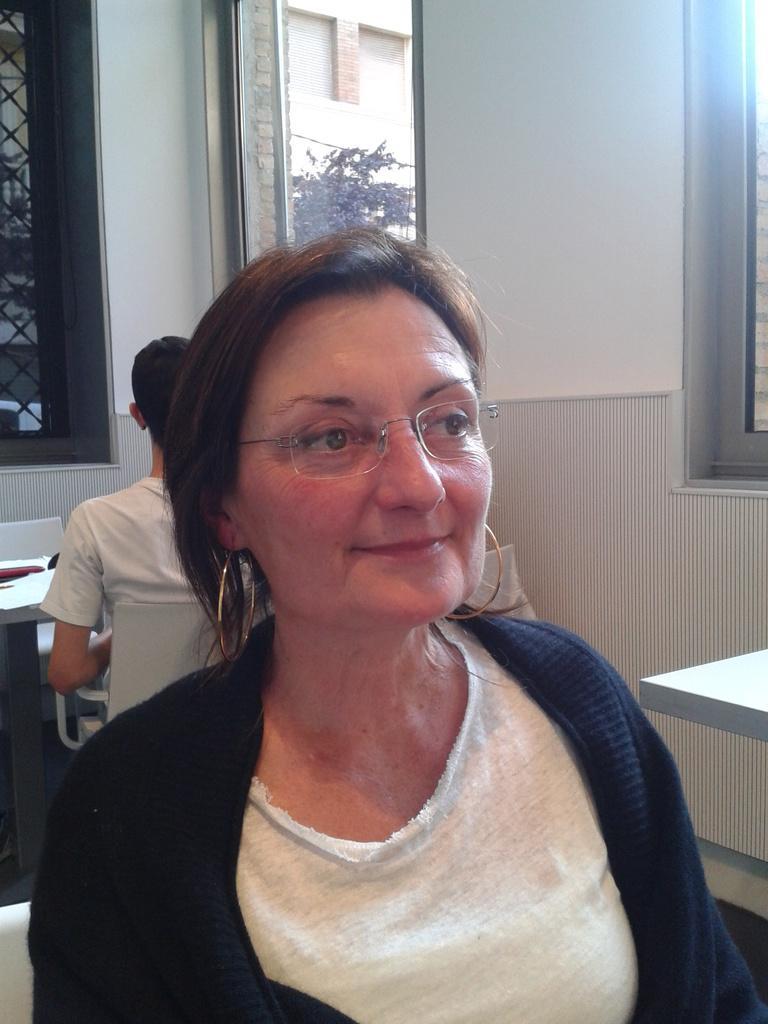Please provide a concise description of this image. In this image I can see the person and the person is wearing white and black color dress. In the background I can see the wall in white color and I can also see few trees in green color. 